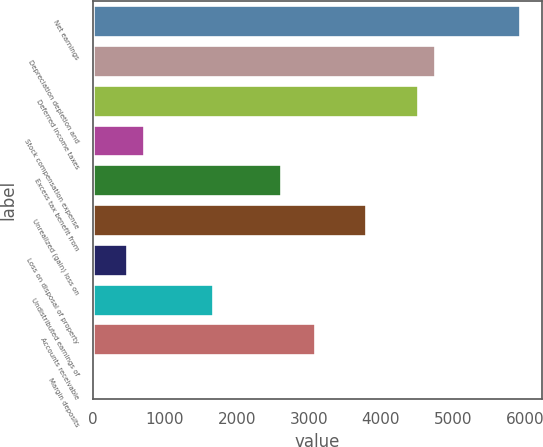Convert chart to OTSL. <chart><loc_0><loc_0><loc_500><loc_500><bar_chart><fcel>Net earnings<fcel>Depreciation depletion and<fcel>Deferred income taxes<fcel>Stock compensation expense<fcel>Excess tax benefit from<fcel>Unrealized (gain) loss on<fcel>Loss on disposal of property<fcel>Undistributed earnings of<fcel>Accounts receivable<fcel>Margin deposits<nl><fcel>5937.8<fcel>4750.4<fcel>4512.92<fcel>713.24<fcel>2613.08<fcel>3800.48<fcel>475.76<fcel>1663.16<fcel>3088.04<fcel>0.8<nl></chart> 